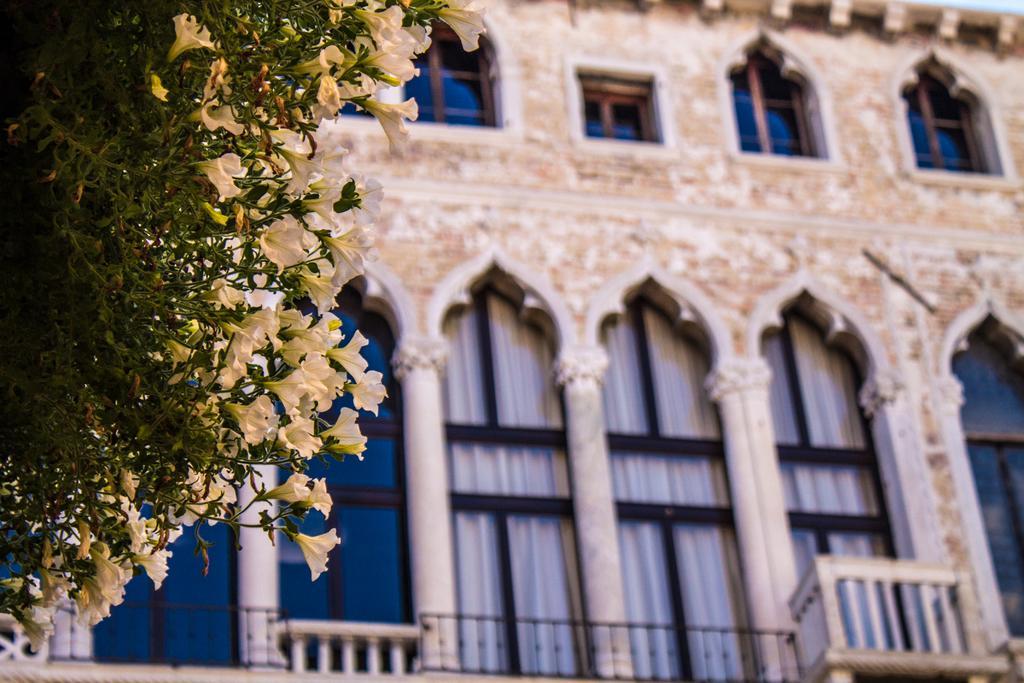Could you give a brief overview of what you see in this image? Left side of image there are few plants having leaves and flowers to it. Behind there is a building having windows. 